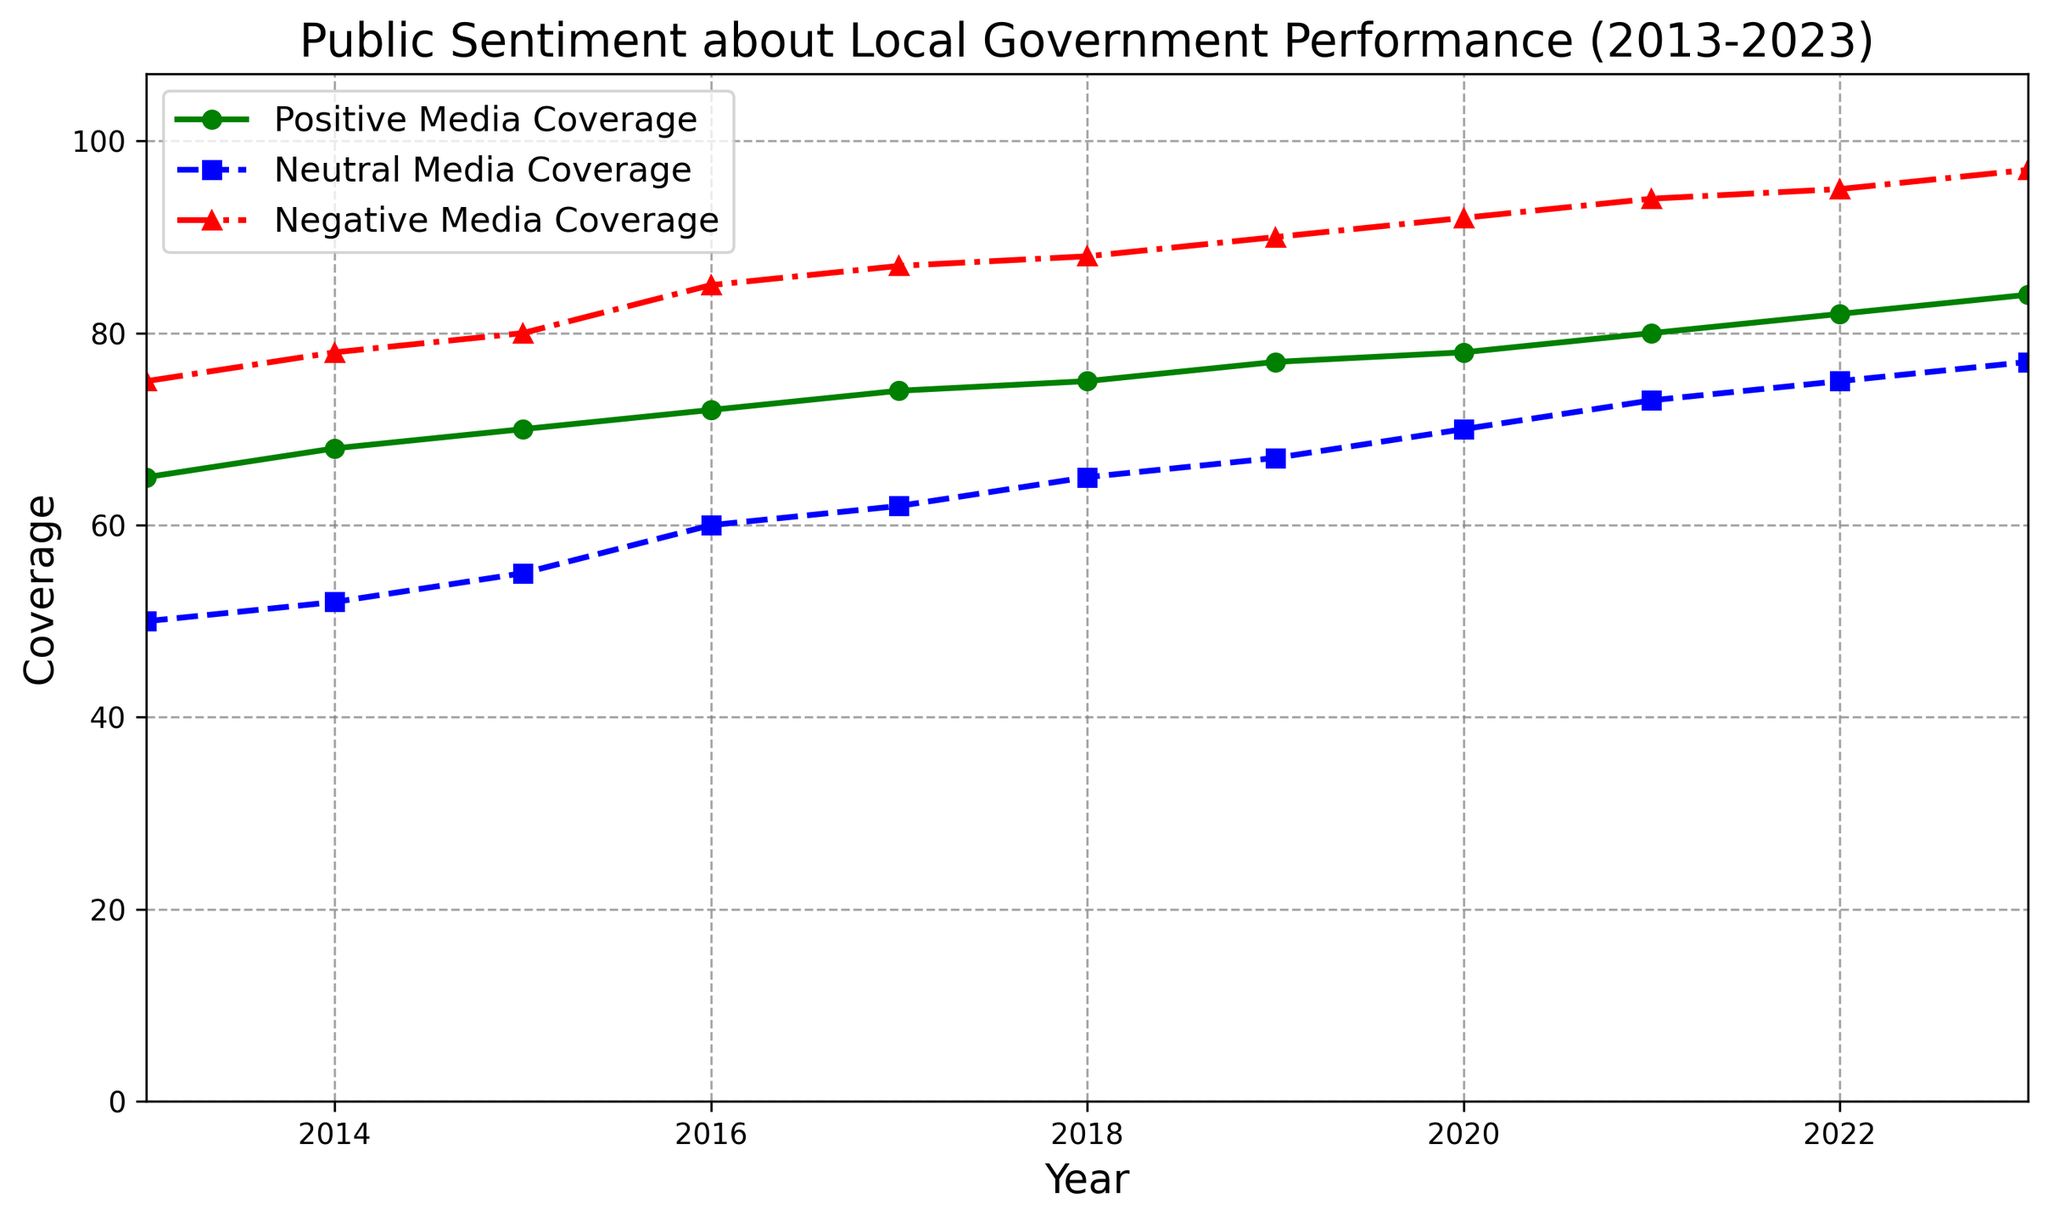What trend do we see in positive media coverage of local government performance from 2013 to 2023? The positive media coverage increases steadily each year from 65 in 2013 to 84 in 2023.
Answer: It increases How does negative media coverage in 2023 compare to positive media coverage in 2018? Negative media coverage in 2023 is 97, while positive media coverage in 2018 is 75. So, negative media coverage in 2023 is higher.
Answer: Negative media coverage is higher In which year did neutral media coverage reach 70? By looking at the blue line (neutral media coverage), it reaches 70 in the year 2020.
Answer: 2020 Which type of media coverage has the highest values throughout the decade? By comparing the heights of the lines, negative media coverage (red line) has the highest values throughout the decade.
Answer: Negative media coverage Calculate the difference in negative media coverage between 2023 and 2013. Negative media coverage in 2023 is 97 and in 2013 is 75. The difference is 97 - 75.
Answer: 22 What year saw both the highest positive and neutral media coverage? The chart shows the last year, 2023, has the highest values for both positive (green line) and neutral (blue line) media coverages.
Answer: 2023 What is the average positive media coverage over the decade? Add the positive coverage values from 2013 to 2023: 65 + 68 + 70 + 72 + 74 + 75 + 77 + 78 + 80 + 82 + 84 = 825. Divide by 11 (number of years): 825 / 11.
Answer: 75 In what year did negative media coverage surpass 90? Following the red line, negative media coverage surpasses 90 in 2019.
Answer: 2019 By how much did neutral media coverage increase from 2013 to 2023? Neutral media coverage in 2013 is 50 and in 2023 is 77. The increase is 77 - 50.
Answer: 27 